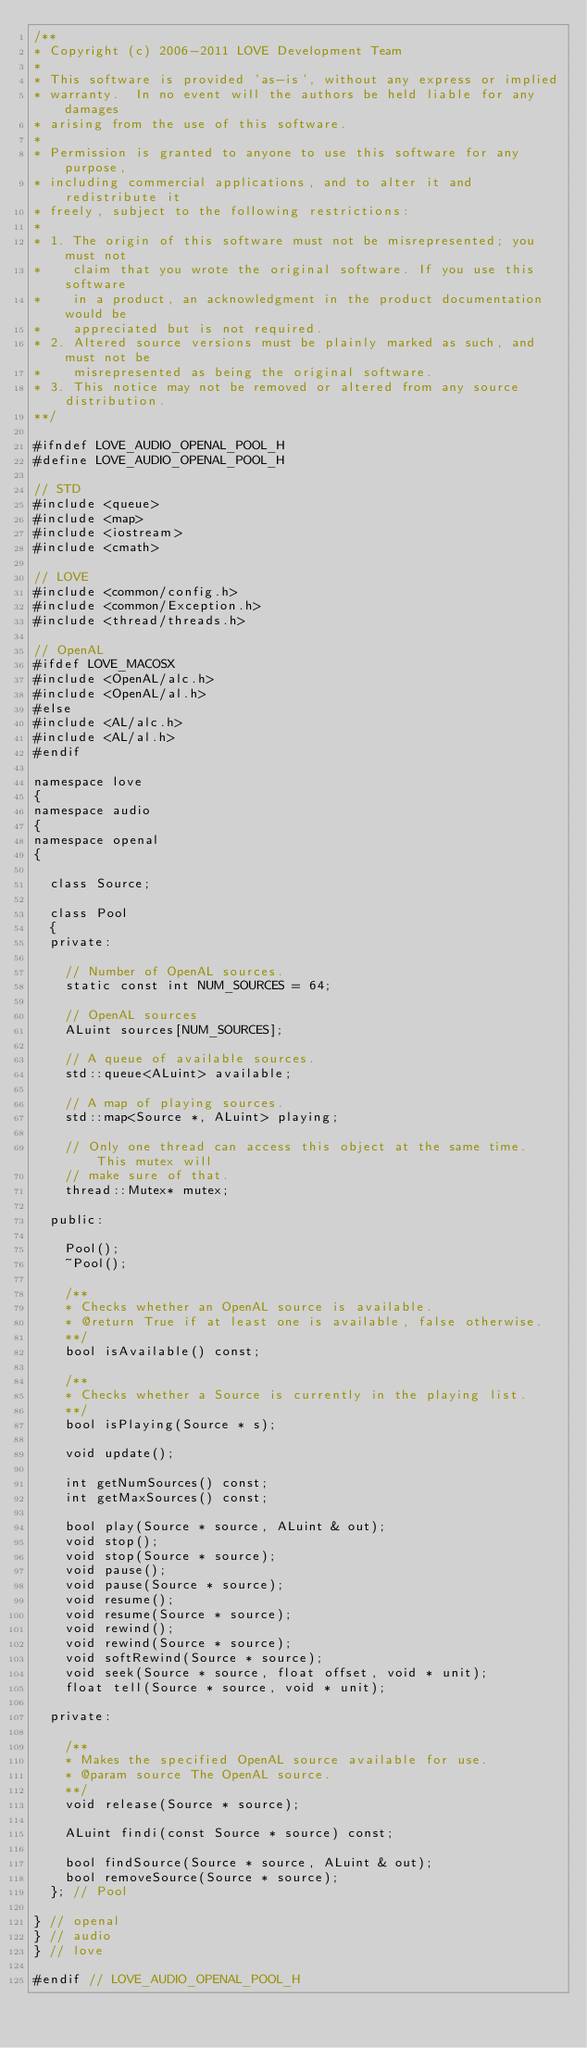Convert code to text. <code><loc_0><loc_0><loc_500><loc_500><_C_>/**
* Copyright (c) 2006-2011 LOVE Development Team
* 
* This software is provided 'as-is', without any express or implied
* warranty.  In no event will the authors be held liable for any damages
* arising from the use of this software.
* 
* Permission is granted to anyone to use this software for any purpose,
* including commercial applications, and to alter it and redistribute it
* freely, subject to the following restrictions:
* 
* 1. The origin of this software must not be misrepresented; you must not
*    claim that you wrote the original software. If you use this software
*    in a product, an acknowledgment in the product documentation would be
*    appreciated but is not required.
* 2. Altered source versions must be plainly marked as such, and must not be
*    misrepresented as being the original software.
* 3. This notice may not be removed or altered from any source distribution.
**/

#ifndef LOVE_AUDIO_OPENAL_POOL_H
#define LOVE_AUDIO_OPENAL_POOL_H

// STD
#include <queue>
#include <map>
#include <iostream>
#include <cmath>

// LOVE
#include <common/config.h>
#include <common/Exception.h>
#include <thread/threads.h>

// OpenAL
#ifdef LOVE_MACOSX
#include <OpenAL/alc.h>
#include <OpenAL/al.h>
#else
#include <AL/alc.h>
#include <AL/al.h>
#endif

namespace love
{
namespace audio
{
namespace openal
{

	class Source;

	class Pool
	{
	private:

		// Number of OpenAL sources.
		static const int NUM_SOURCES = 64;

		// OpenAL sources
		ALuint sources[NUM_SOURCES];

		// A queue of available sources.
		std::queue<ALuint> available;

		// A map of playing sources.
		std::map<Source *, ALuint> playing;

		// Only one thread can access this object at the same time. This mutex will
		// make sure of that.
		thread::Mutex* mutex;

	public:

		Pool();
		~Pool();

		/**
		* Checks whether an OpenAL source is available.
		* @return True if at least one is available, false otherwise.
		**/
		bool isAvailable() const;

		/**
		* Checks whether a Source is currently in the playing list.
		**/
		bool isPlaying(Source * s);

		void update();

		int getNumSources() const;
		int getMaxSources() const;

		bool play(Source * source, ALuint & out);
		void stop();
		void stop(Source * source);
		void pause();
		void pause(Source * source);
		void resume();
		void resume(Source * source);
		void rewind();
		void rewind(Source * source);
		void softRewind(Source * source);
		void seek(Source * source, float offset, void * unit);
		float tell(Source * source, void * unit);

	private:

		/**
		* Makes the specified OpenAL source available for use.
		* @param source The OpenAL source.
		**/
		void release(Source * source);

		ALuint findi(const Source * source) const;

		bool findSource(Source * source, ALuint & out);
		bool removeSource(Source * source);
	}; // Pool

} // openal
} // audio
} // love

#endif // LOVE_AUDIO_OPENAL_POOL_H
</code> 